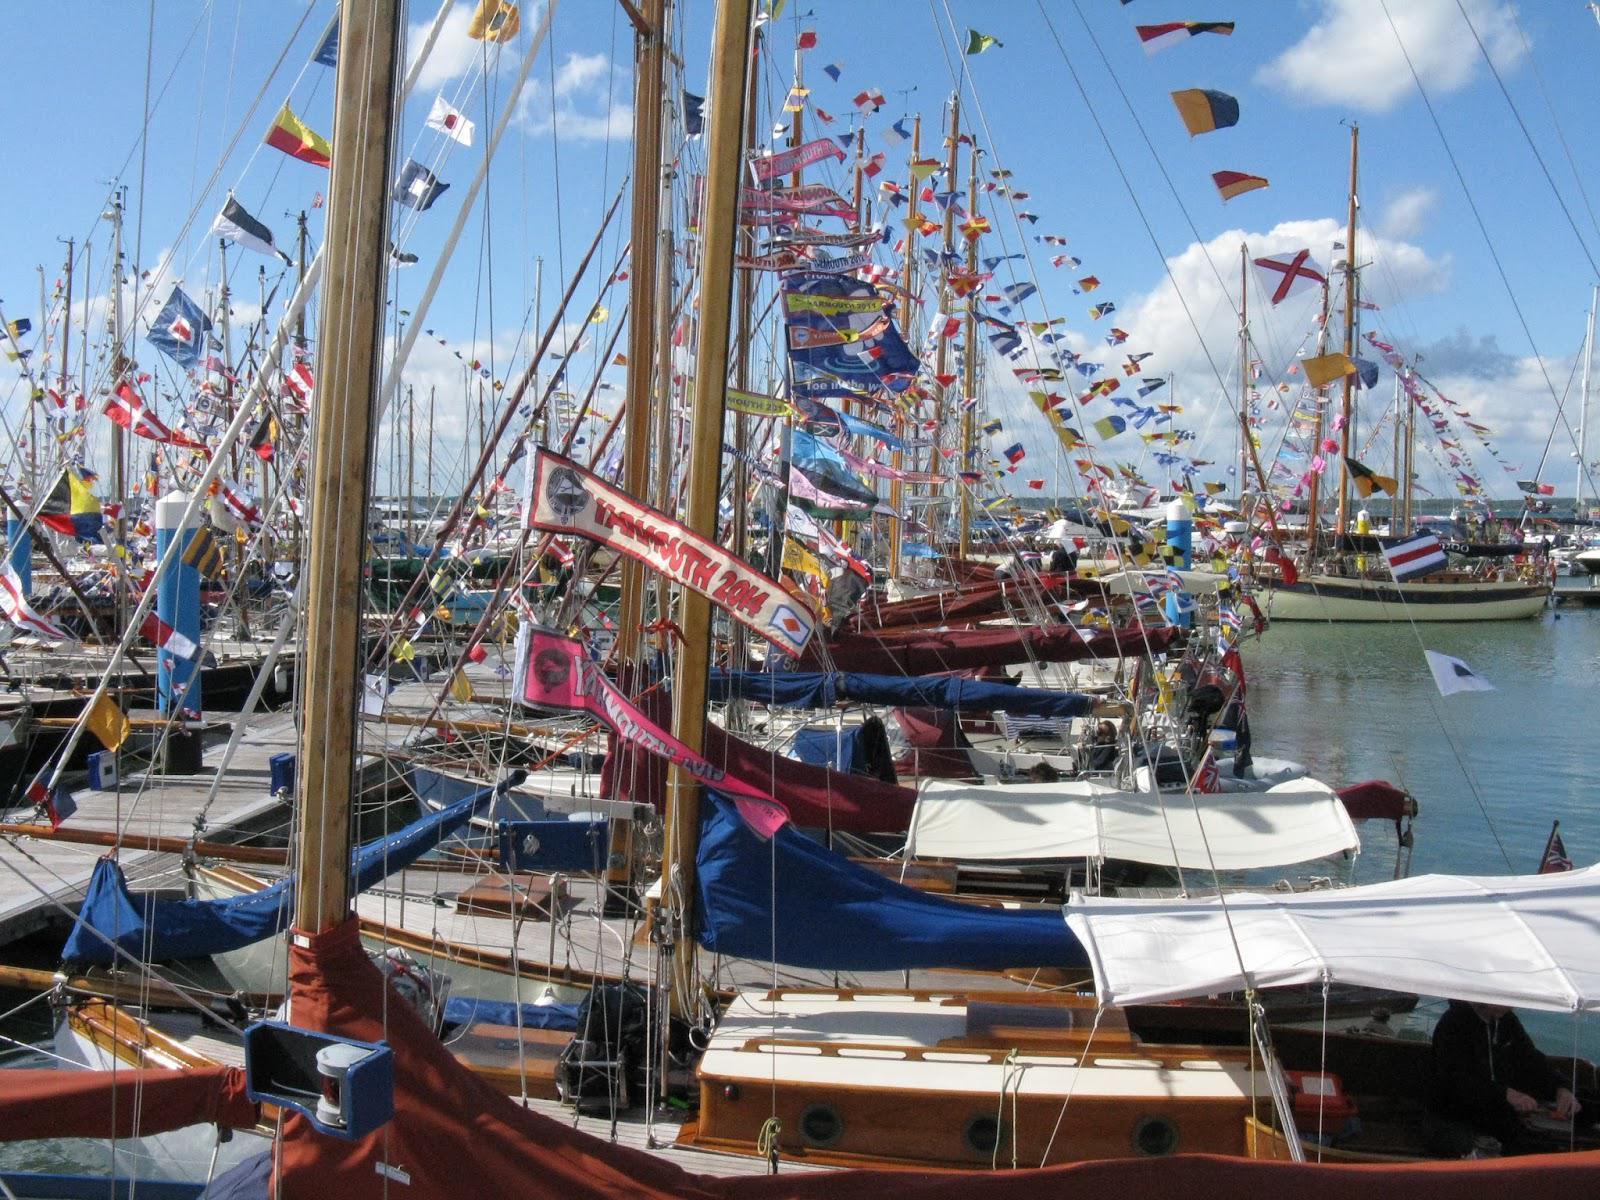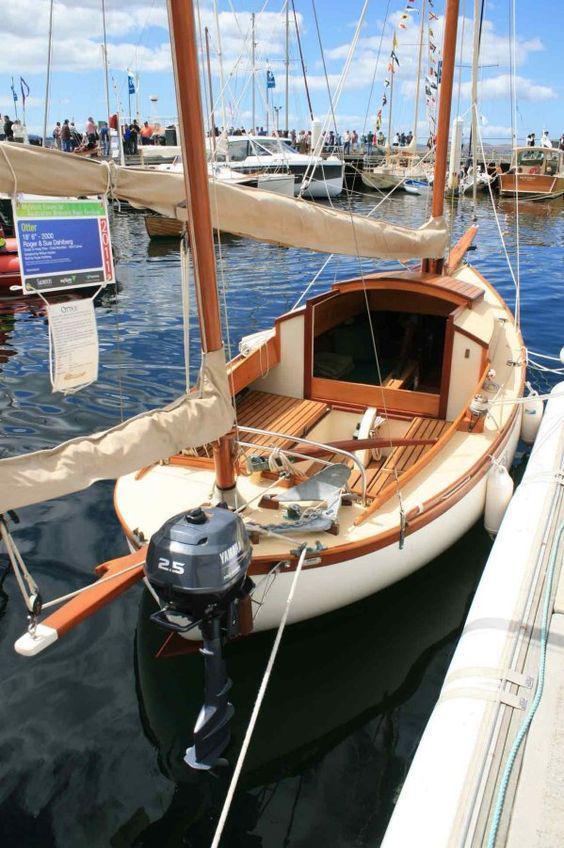The first image is the image on the left, the second image is the image on the right. Analyze the images presented: Is the assertion "A sailboat on open water in one image has red sails and at least one person on the boat." valid? Answer yes or no. No. 